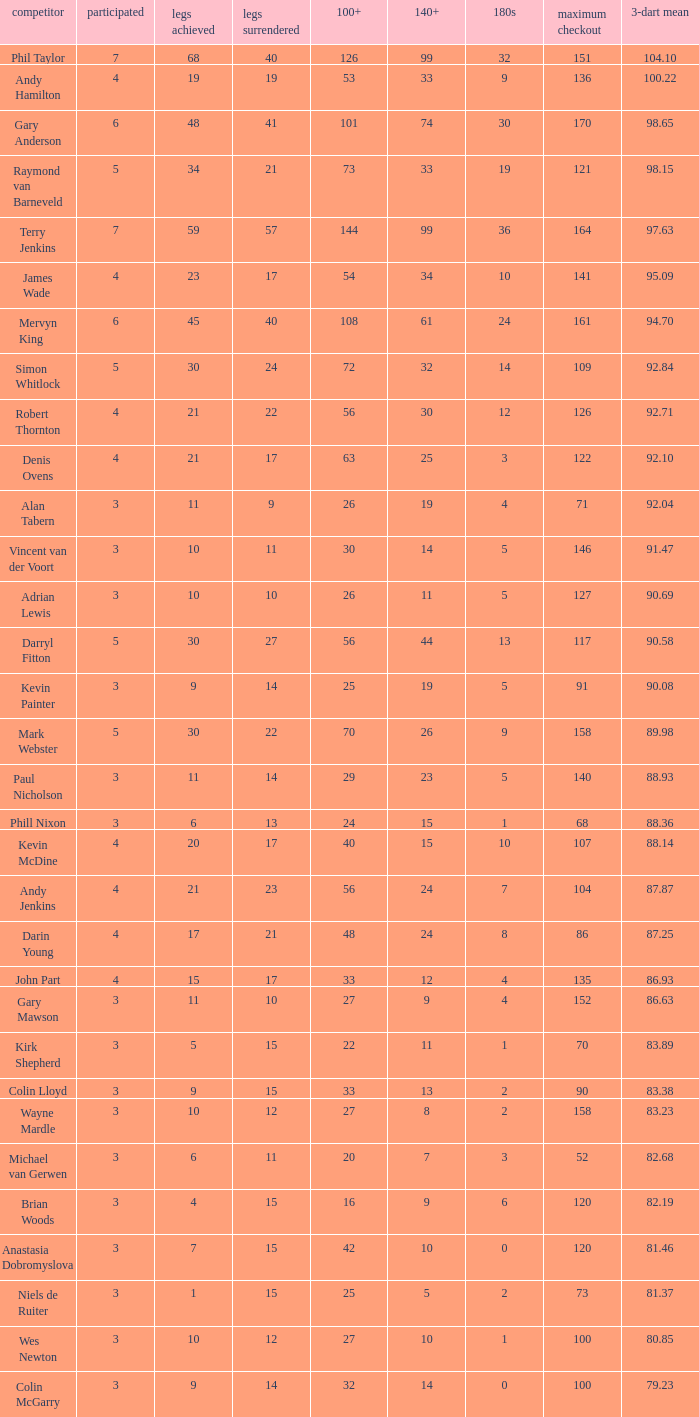What is the played number when the high checkout is 135? 4.0. 